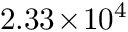Convert formula to latex. <formula><loc_0><loc_0><loc_500><loc_500>2 . 3 3 \, \times \, 1 0 ^ { 4 }</formula> 